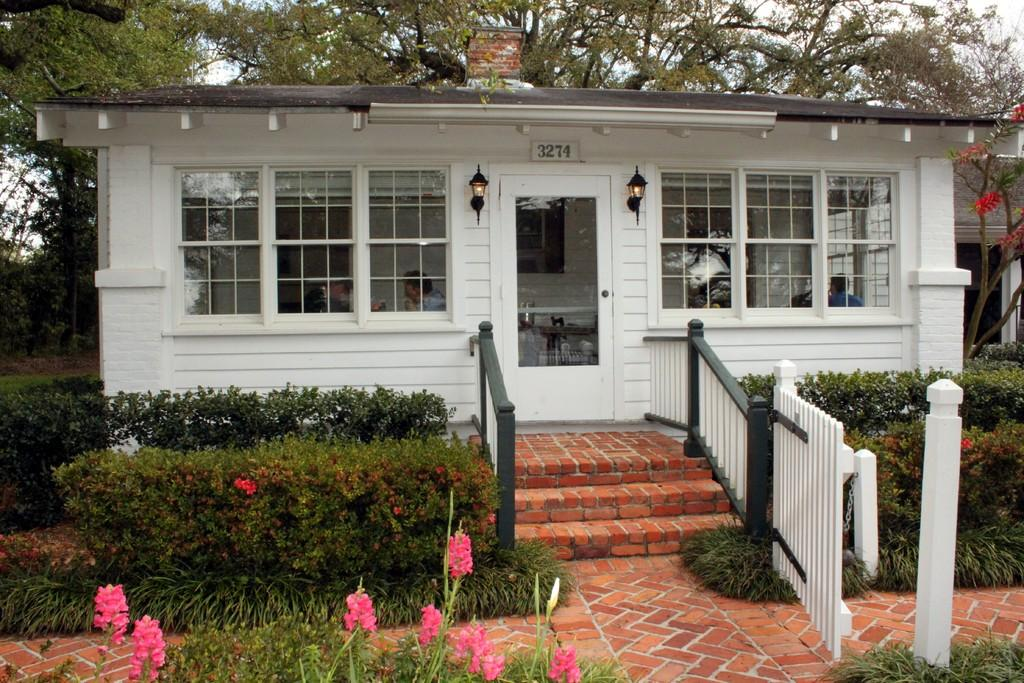What type of vegetation is at the front of the image? There are plants at the front of the image. What structure is located at the center of the image? There is a building at the center of the image. What architectural feature is in front of the building? There are stairs in front of the building. What can be seen in the background of the image? There are trees and the sky visible in the background of the image. Where is the jar located in the image? There is no jar present in the image. Can you describe the zipper on the building in the image? There is no zipper on the building in the image; it is a regular structure. 